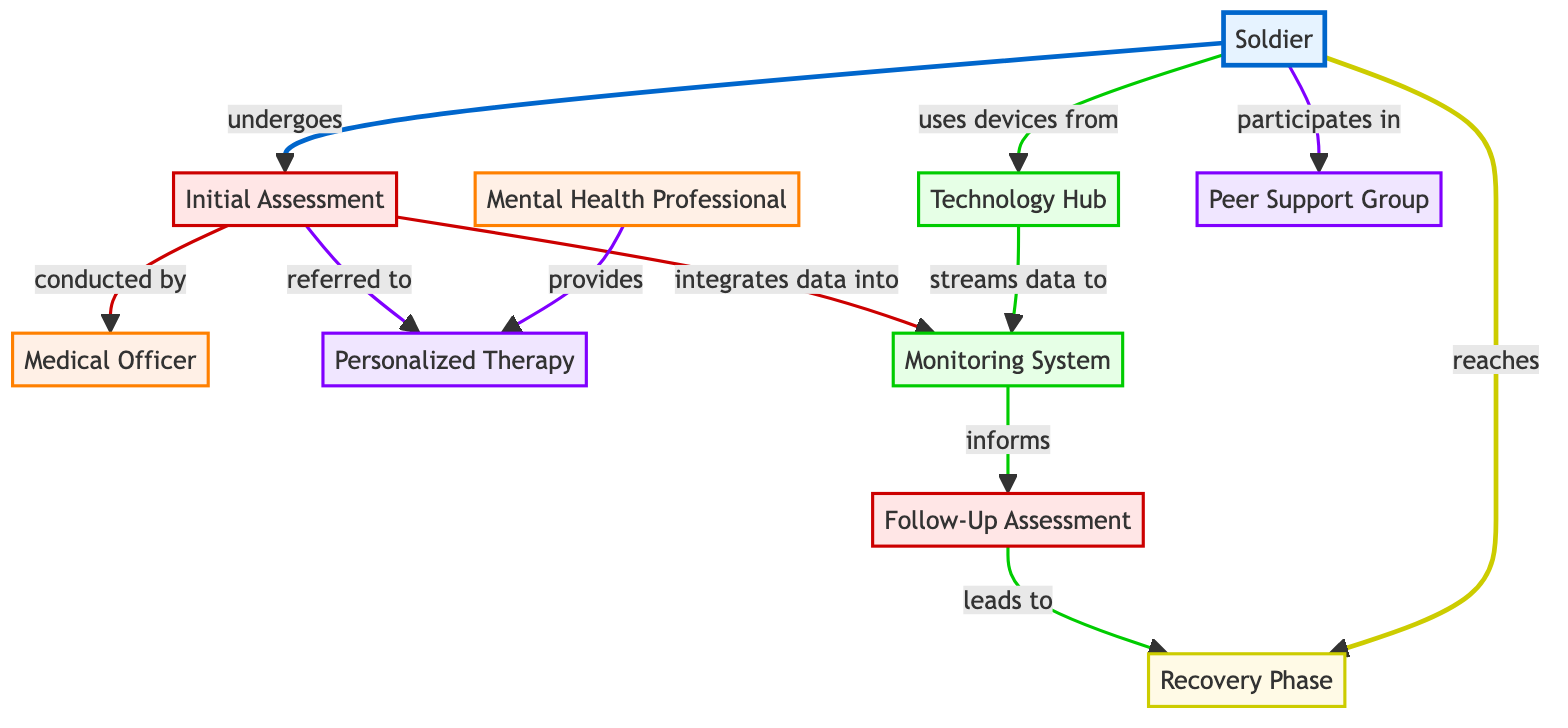What is the first step for the soldier in the diagram? The first step for the soldier is to undergo the Initial Assessment, as indicated by the connection from the Soldier node to the Initial Assessment node.
Answer: Initial Assessment How many support options are there for the soldier? There are two support options available for the soldier: Peer Support Group and Personalized Therapy, as those are the two nodes connected to the soldier.
Answer: 2 Who conducts the initial assessment? The initial assessment is conducted by the Medical Officer, as shown by the link from the Initial Assessment node to the Medical Officer node.
Answer: Medical Officer What leads to the Recovery Phase? The Follow-Up Assessment leads to the Recovery Phase, which is indicated by the arrow connecting these two nodes in the diagram.
Answer: Follow-Up Assessment What kind of technology is used in the system? The technology used in the system includes the Monitoring System and devices from the Technology Hub, linking the soldier to data integration and monitoring.
Answer: Monitoring System and devices Which nodes are part of the support options in the diagram? The nodes part of the support options are Peer Support Group and Personalized Therapy, as these are both categories connected to the soldier for support.
Answer: Peer Support Group and Personalized Therapy How does the Monitoring System receive data? The Monitoring System receives data by integrating information from the Initial Assessment and streaming data from the devices sourced from the Technology Hub, creating a feedback loop for monitoring soldier health.
Answer: Integrates data and streams data What phase follows the Initial Assessment? The phase that follows the Initial Assessment is the Follow-Up Assessment since it comes directly after in the flow of the diagram.
Answer: Follow-Up Assessment 